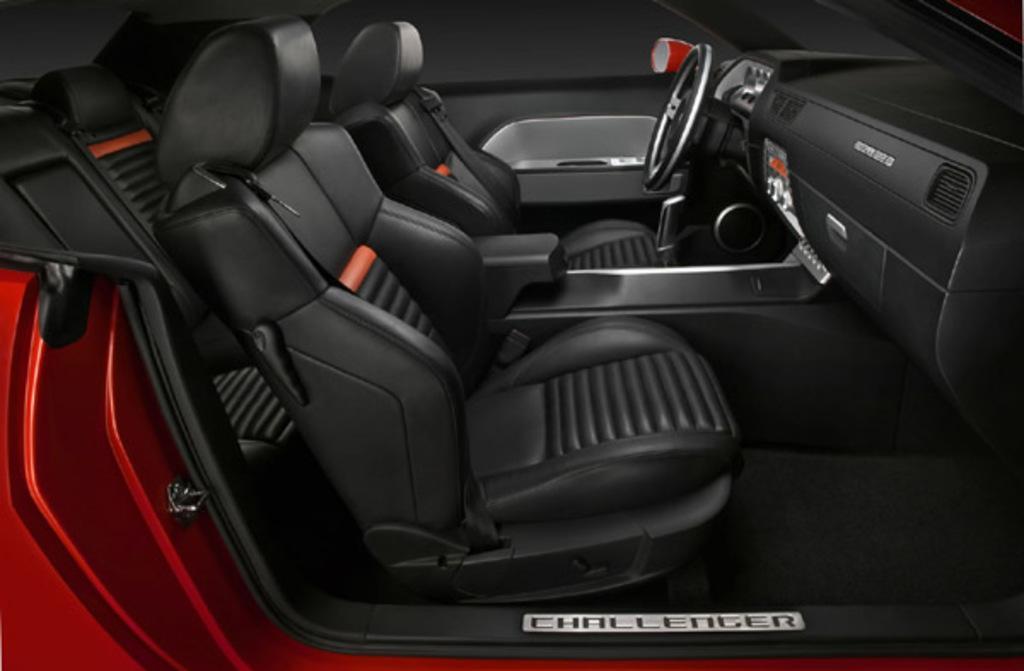Could you give a brief overview of what you see in this image? In this image we can see inside view of a red color car. 